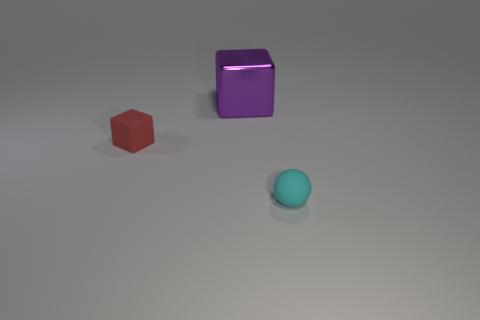Are there any other things that have the same material as the purple object?
Offer a terse response. No. There is a purple cube behind the small cyan rubber thing that is on the right side of the tiny matte object behind the small matte ball; what is its material?
Give a very brief answer. Metal. How many other objects are the same size as the purple object?
Provide a succinct answer. 0. Are there more objects to the right of the tiny red block than small red matte things?
Make the answer very short. Yes. The ball that is the same size as the red block is what color?
Offer a terse response. Cyan. There is a matte thing left of the big cube; what number of small red things are to the right of it?
Provide a short and direct response. 0. What number of objects are either tiny matte objects behind the cyan ball or gray shiny blocks?
Keep it short and to the point. 1. What number of other spheres are made of the same material as the small cyan sphere?
Your response must be concise. 0. Are there the same number of cyan rubber balls to the right of the small cyan matte thing and gray rubber spheres?
Give a very brief answer. Yes. There is a cube behind the red matte object; how big is it?
Your response must be concise. Large. 